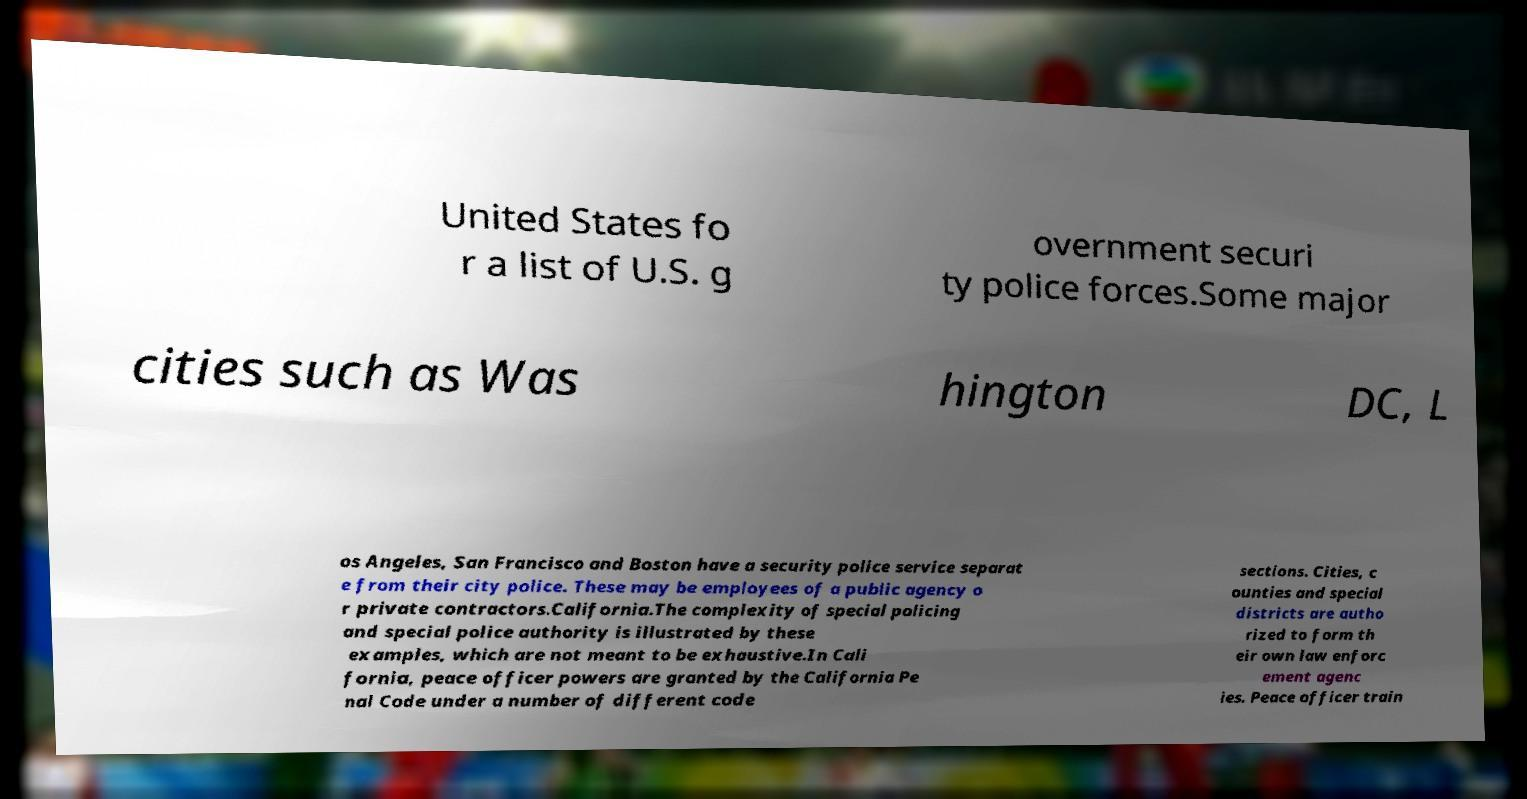There's text embedded in this image that I need extracted. Can you transcribe it verbatim? United States fo r a list of U.S. g overnment securi ty police forces.Some major cities such as Was hington DC, L os Angeles, San Francisco and Boston have a security police service separat e from their city police. These may be employees of a public agency o r private contractors.California.The complexity of special policing and special police authority is illustrated by these examples, which are not meant to be exhaustive.In Cali fornia, peace officer powers are granted by the California Pe nal Code under a number of different code sections. Cities, c ounties and special districts are autho rized to form th eir own law enforc ement agenc ies. Peace officer train 